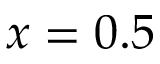Convert formula to latex. <formula><loc_0><loc_0><loc_500><loc_500>x = 0 . 5</formula> 